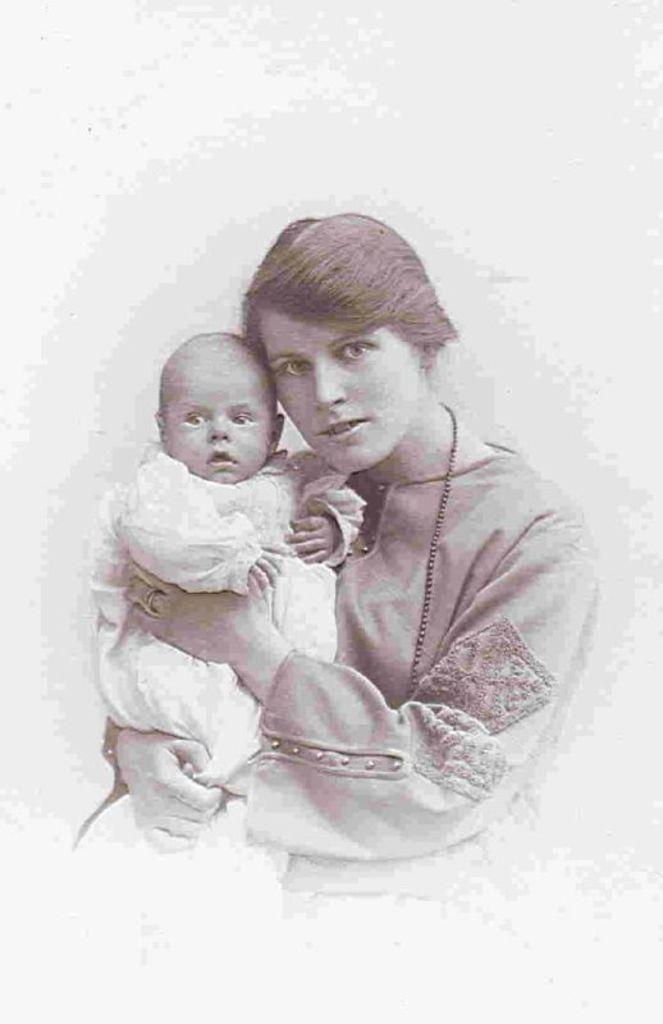How many people are present in the image? There are two persons in the image. What can be observed about the background of the image? The background of the image is white. What type of lizards can be seen crawling on the car in the image? There is no car or lizards present in the image; it only features two persons with a white background. 